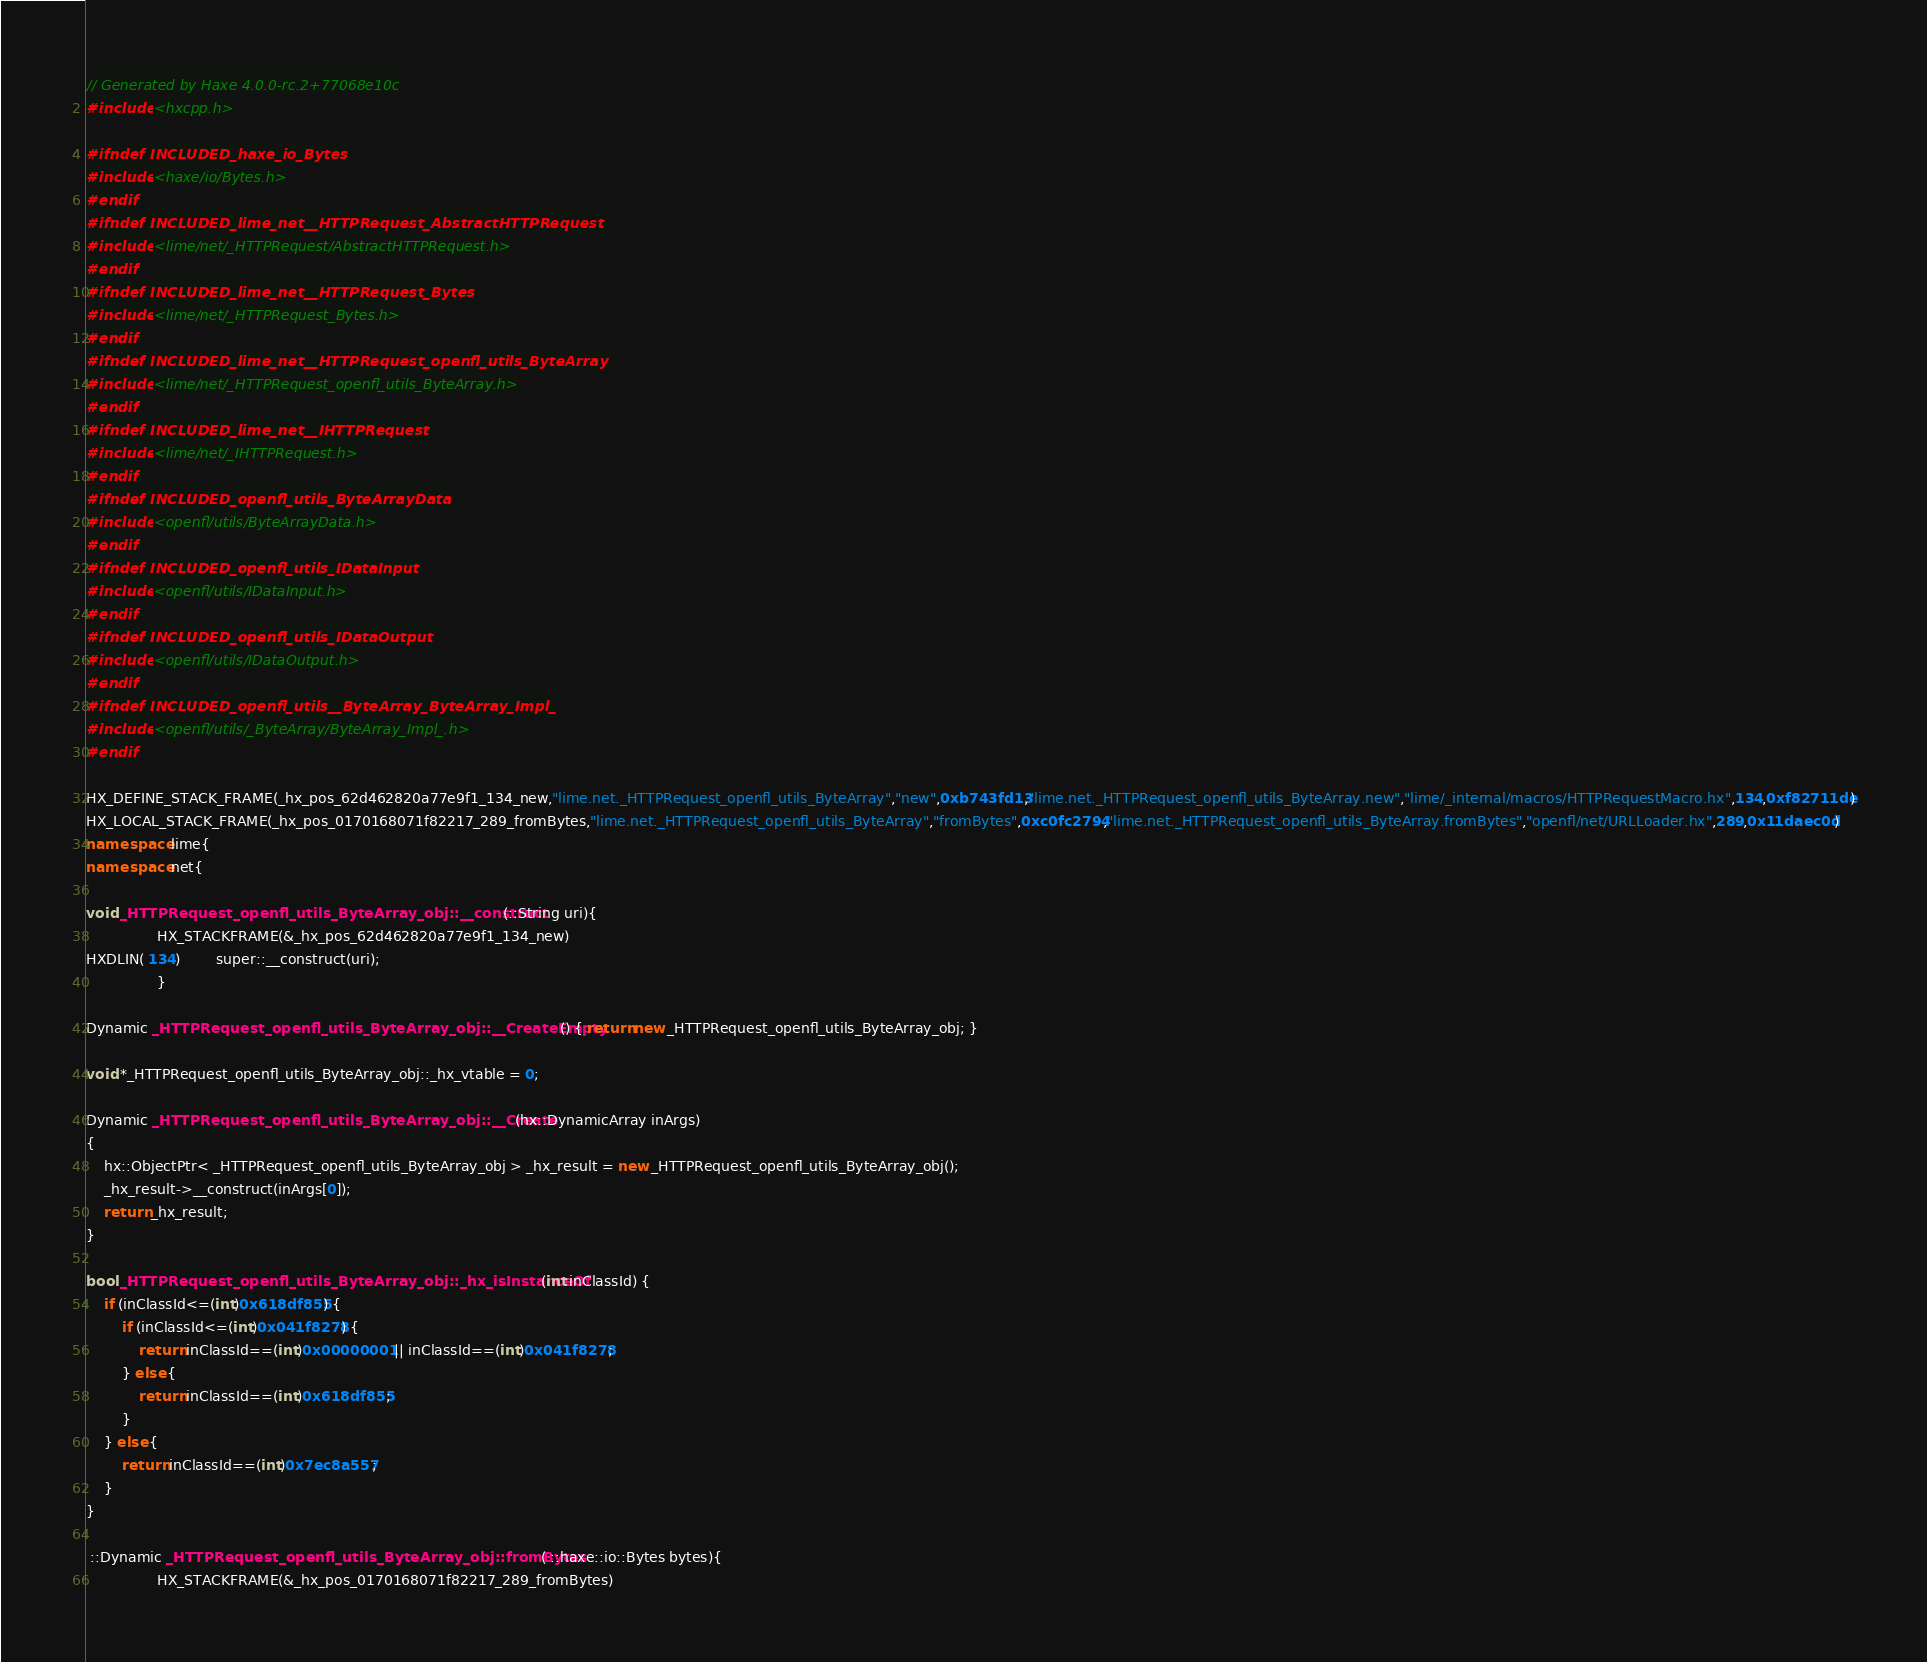Convert code to text. <code><loc_0><loc_0><loc_500><loc_500><_C++_>// Generated by Haxe 4.0.0-rc.2+77068e10c
#include <hxcpp.h>

#ifndef INCLUDED_haxe_io_Bytes
#include <haxe/io/Bytes.h>
#endif
#ifndef INCLUDED_lime_net__HTTPRequest_AbstractHTTPRequest
#include <lime/net/_HTTPRequest/AbstractHTTPRequest.h>
#endif
#ifndef INCLUDED_lime_net__HTTPRequest_Bytes
#include <lime/net/_HTTPRequest_Bytes.h>
#endif
#ifndef INCLUDED_lime_net__HTTPRequest_openfl_utils_ByteArray
#include <lime/net/_HTTPRequest_openfl_utils_ByteArray.h>
#endif
#ifndef INCLUDED_lime_net__IHTTPRequest
#include <lime/net/_IHTTPRequest.h>
#endif
#ifndef INCLUDED_openfl_utils_ByteArrayData
#include <openfl/utils/ByteArrayData.h>
#endif
#ifndef INCLUDED_openfl_utils_IDataInput
#include <openfl/utils/IDataInput.h>
#endif
#ifndef INCLUDED_openfl_utils_IDataOutput
#include <openfl/utils/IDataOutput.h>
#endif
#ifndef INCLUDED_openfl_utils__ByteArray_ByteArray_Impl_
#include <openfl/utils/_ByteArray/ByteArray_Impl_.h>
#endif

HX_DEFINE_STACK_FRAME(_hx_pos_62d462820a77e9f1_134_new,"lime.net._HTTPRequest_openfl_utils_ByteArray","new",0xb743fd13,"lime.net._HTTPRequest_openfl_utils_ByteArray.new","lime/_internal/macros/HTTPRequestMacro.hx",134,0xf82711de)
HX_LOCAL_STACK_FRAME(_hx_pos_0170168071f82217_289_fromBytes,"lime.net._HTTPRequest_openfl_utils_ByteArray","fromBytes",0xc0fc2794,"lime.net._HTTPRequest_openfl_utils_ByteArray.fromBytes","openfl/net/URLLoader.hx",289,0x11daec0d)
namespace lime{
namespace net{

void _HTTPRequest_openfl_utils_ByteArray_obj::__construct(::String uri){
            	HX_STACKFRAME(&_hx_pos_62d462820a77e9f1_134_new)
HXDLIN( 134)		super::__construct(uri);
            	}

Dynamic _HTTPRequest_openfl_utils_ByteArray_obj::__CreateEmpty() { return new _HTTPRequest_openfl_utils_ByteArray_obj; }

void *_HTTPRequest_openfl_utils_ByteArray_obj::_hx_vtable = 0;

Dynamic _HTTPRequest_openfl_utils_ByteArray_obj::__Create(hx::DynamicArray inArgs)
{
	hx::ObjectPtr< _HTTPRequest_openfl_utils_ByteArray_obj > _hx_result = new _HTTPRequest_openfl_utils_ByteArray_obj();
	_hx_result->__construct(inArgs[0]);
	return _hx_result;
}

bool _HTTPRequest_openfl_utils_ByteArray_obj::_hx_isInstanceOf(int inClassId) {
	if (inClassId<=(int)0x618df855) {
		if (inClassId<=(int)0x041f8278) {
			return inClassId==(int)0x00000001 || inClassId==(int)0x041f8278;
		} else {
			return inClassId==(int)0x618df855;
		}
	} else {
		return inClassId==(int)0x7ec8a557;
	}
}

 ::Dynamic _HTTPRequest_openfl_utils_ByteArray_obj::fromBytes( ::haxe::io::Bytes bytes){
            	HX_STACKFRAME(&_hx_pos_0170168071f82217_289_fromBytes)</code> 